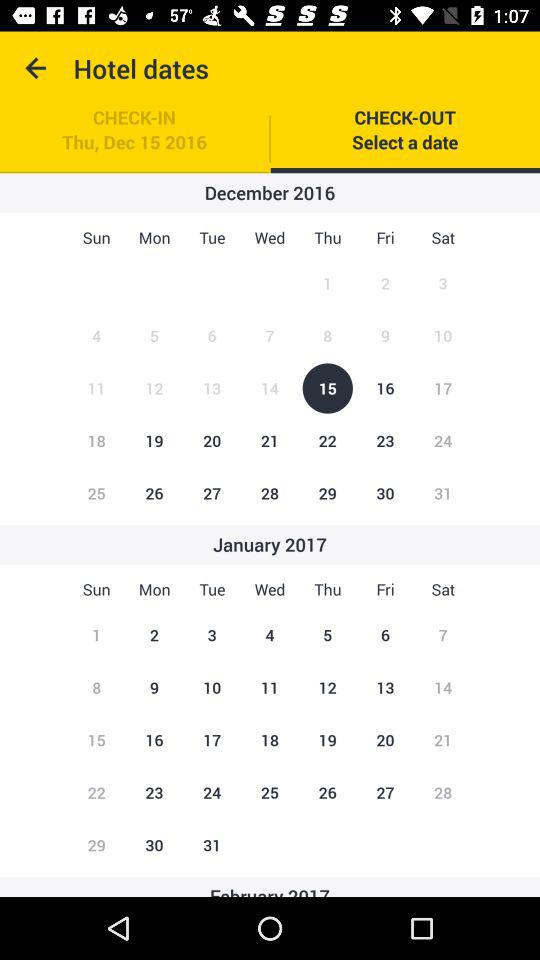What is the check-in date? The check-in date was December 15, 2016, Thursday. 